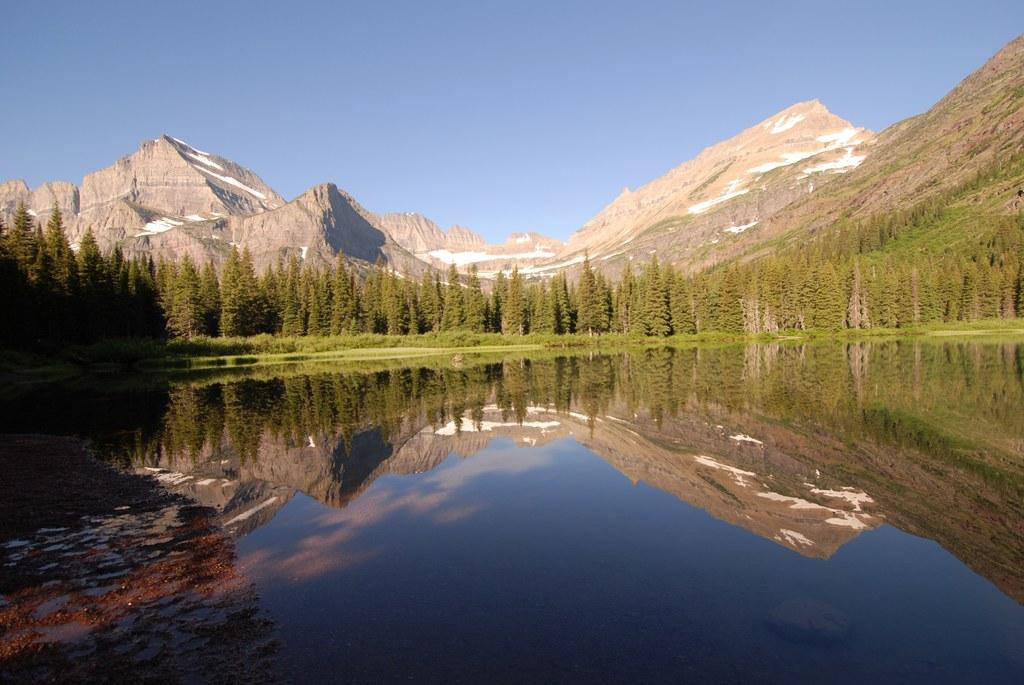What is the primary element visible in the image? There is water in the image. What type of vegetation is near the water? There are many trees near the water. What can be seen in the distance in the image? There are mountains in the background of the image. What is the color of the sky in the background of the image? The sky is blue in the background of the image. What type of jar is being used for treatment in the image? There is no jar or treatment present in the image; it features water, trees, mountains, and a blue sky. 